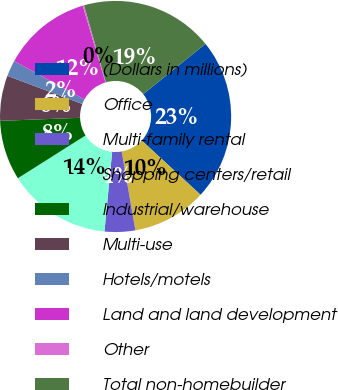<chart> <loc_0><loc_0><loc_500><loc_500><pie_chart><fcel>(Dollars in millions)<fcel>Office<fcel>Multi-family rental<fcel>Shopping centers/retail<fcel>Industrial/warehouse<fcel>Multi-use<fcel>Hotels/motels<fcel>Land and land development<fcel>Other<fcel>Total non-homebuilder<nl><fcel>22.66%<fcel>10.41%<fcel>4.28%<fcel>14.49%<fcel>8.37%<fcel>6.32%<fcel>2.24%<fcel>12.45%<fcel>0.19%<fcel>18.58%<nl></chart> 